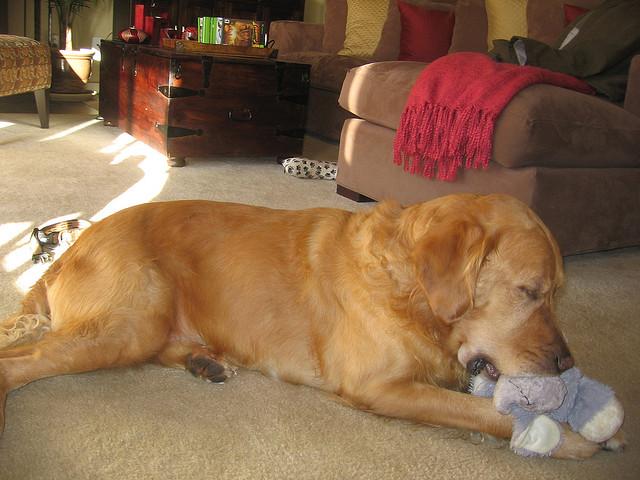Is this a yellow lab?
Write a very short answer. Yes. What is the dog biting?
Answer briefly. Toy. Is the dog happy?
Answer briefly. Yes. What kind of dog is that?
Answer briefly. Labrador. Where is the dog?
Write a very short answer. Floor. 